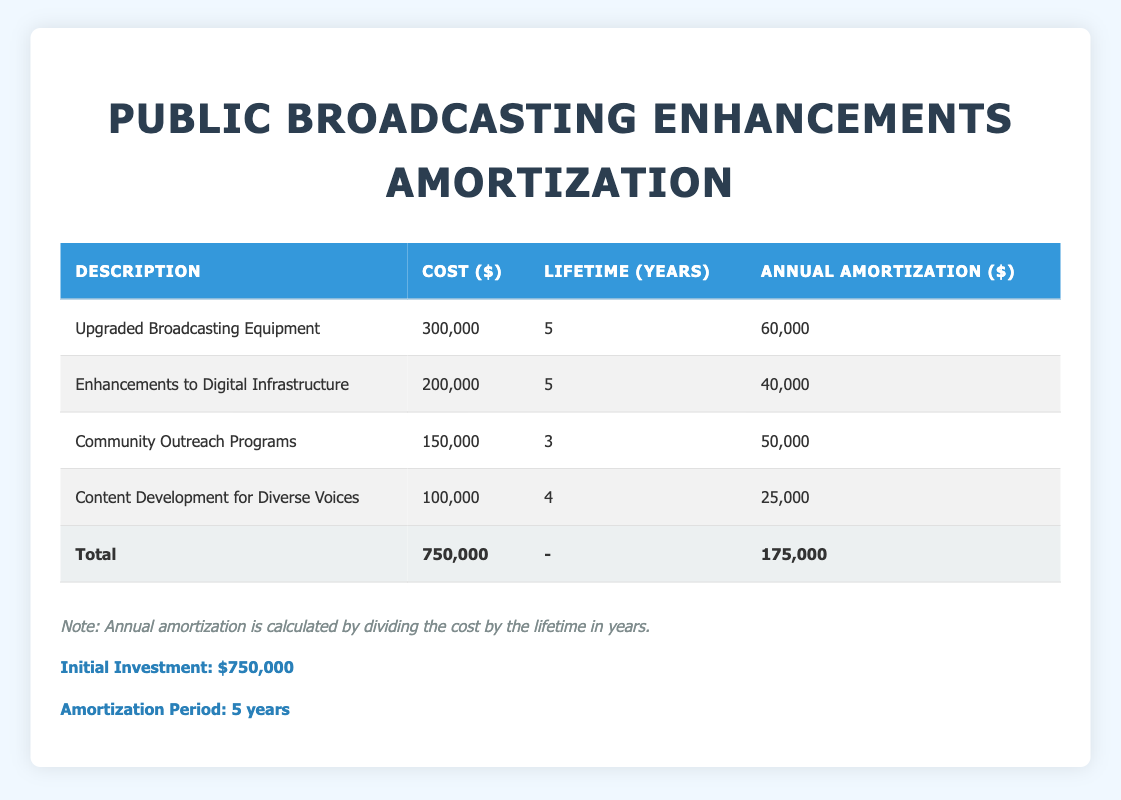What is the annual amortization cost for "Upgraded Broadcasting Equipment"? According to the table, the annual amortization for "Upgraded Broadcasting Equipment" is listed under the "Annual Amortization" column, which shows a value of 60,000.
Answer: 60,000 How much is allocated annually for "Community Outreach Programs"? The table indicates that the annual amortization for "Community Outreach Programs" is listed as 50,000 under the "Annual Amortization" column.
Answer: 50,000 What is the total cost of the four expenses listed in the table? To find the total cost, we add the costs of all expenses: 300,000 + 200,000 + 150,000 + 100,000 = 750,000. The total cost matches the initial investment, as shown in the final row.
Answer: 750,000 Is the annual amortization for "Content Development for Diverse Voices" greater than 25,000? The table shows that the annual amortization for "Content Development for Diverse Voices" is 25,000, so the statement is false.
Answer: No Which expense has the shortest life span? The expense with the shortest lifespan can be found by comparing the "Lifetime (Years)" column. "Community Outreach Programs" has a lifetime of 3 years, which is less than the others.
Answer: Community Outreach Programs What is the average annual amortization across all listed expenses? To find the average annual amortization, we total the annual amortizations: 60,000 + 40,000 + 50,000 + 25,000 = 175,000, and then divide by the number of expenses (4). Thus, the average is 175,000 / 4 = 43,750.
Answer: 43,750 Is the total amortization cost over the five years higher than the initial investment? The total amortization cost over the five years is 175,000, which is the same as the initial investment total, thus the answer is false.
Answer: No What percentage of the total costs is attributed to "Enhancements to Digital Infrastructure"? The percentage can be calculated by taking the cost of "Enhancements to Digital Infrastructure" which is 200,000, dividing by the total cost of 750,000, and multiplying by 100. This gives us (200,000 / 750,000) * 100 = 26.67%.
Answer: 26.67% What is the total annual amortization for all expenses combined? The total annual amortization for all expenses is found by adding together the values from the "Annual Amortization" column: 60,000 + 40,000 + 50,000 + 25,000 = 175,000.
Answer: 175,000 